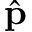Convert formula to latex. <formula><loc_0><loc_0><loc_500><loc_500>\hat { p }</formula> 